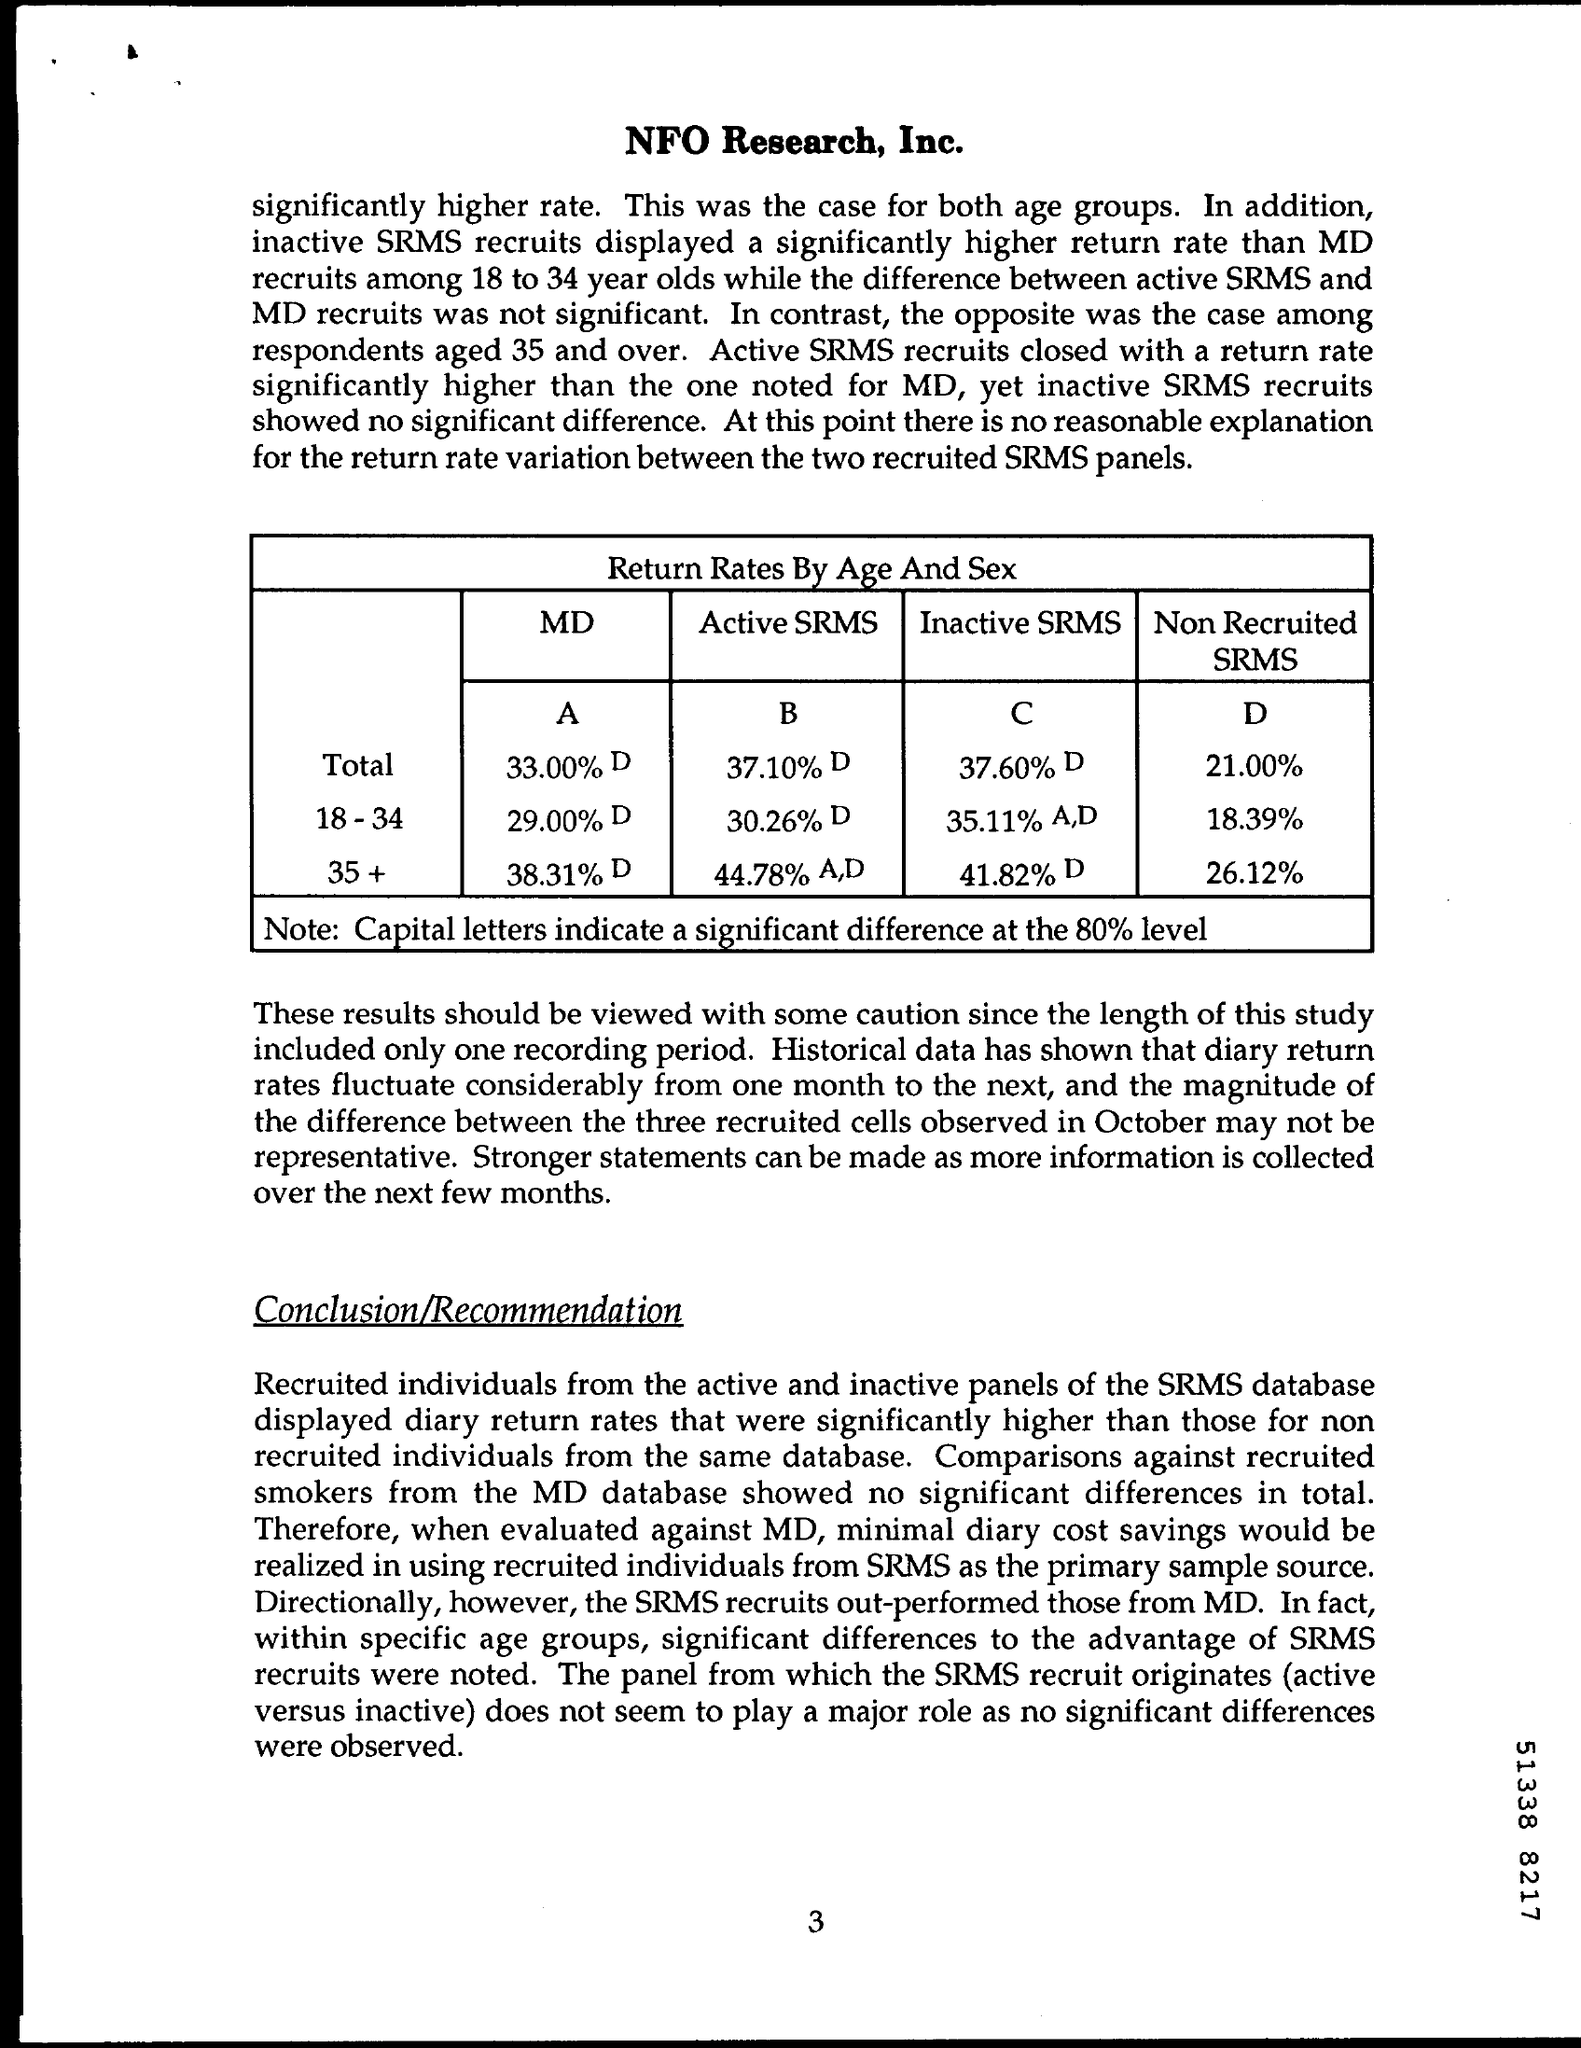What statistical significance level is mentioned in the document, and what does it indicate? The document mentions 'a significant difference at the 80% level,' indicated by capital letters in the table. This suggests that the results are considered statistically significant if there is less than a 20% probability that the observed difference could have occurred by chance. This level is lower than the more commonly used 95% confidence level, indicating weaker statistical evidence. 